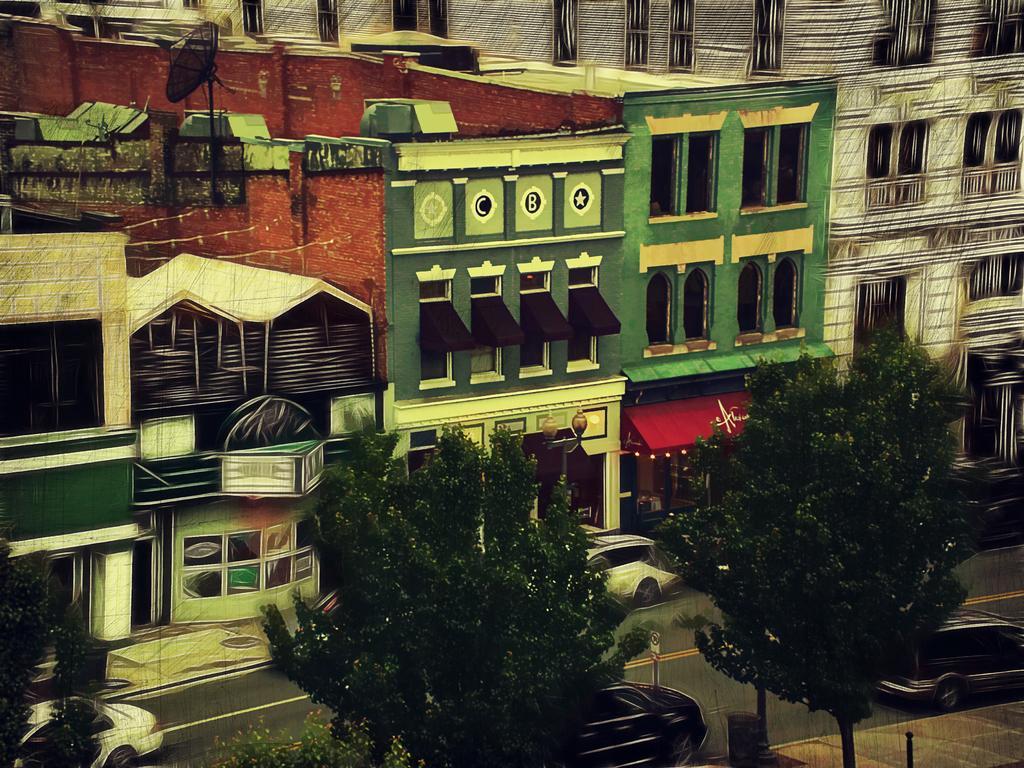In one or two sentences, can you explain what this image depicts? There are number of buildings with windows in a line by line order on the road. There is a road in front of these building and cars are going on this road. On the other side of the road there are trees and poles located. There is antenna on one of the buildings. 